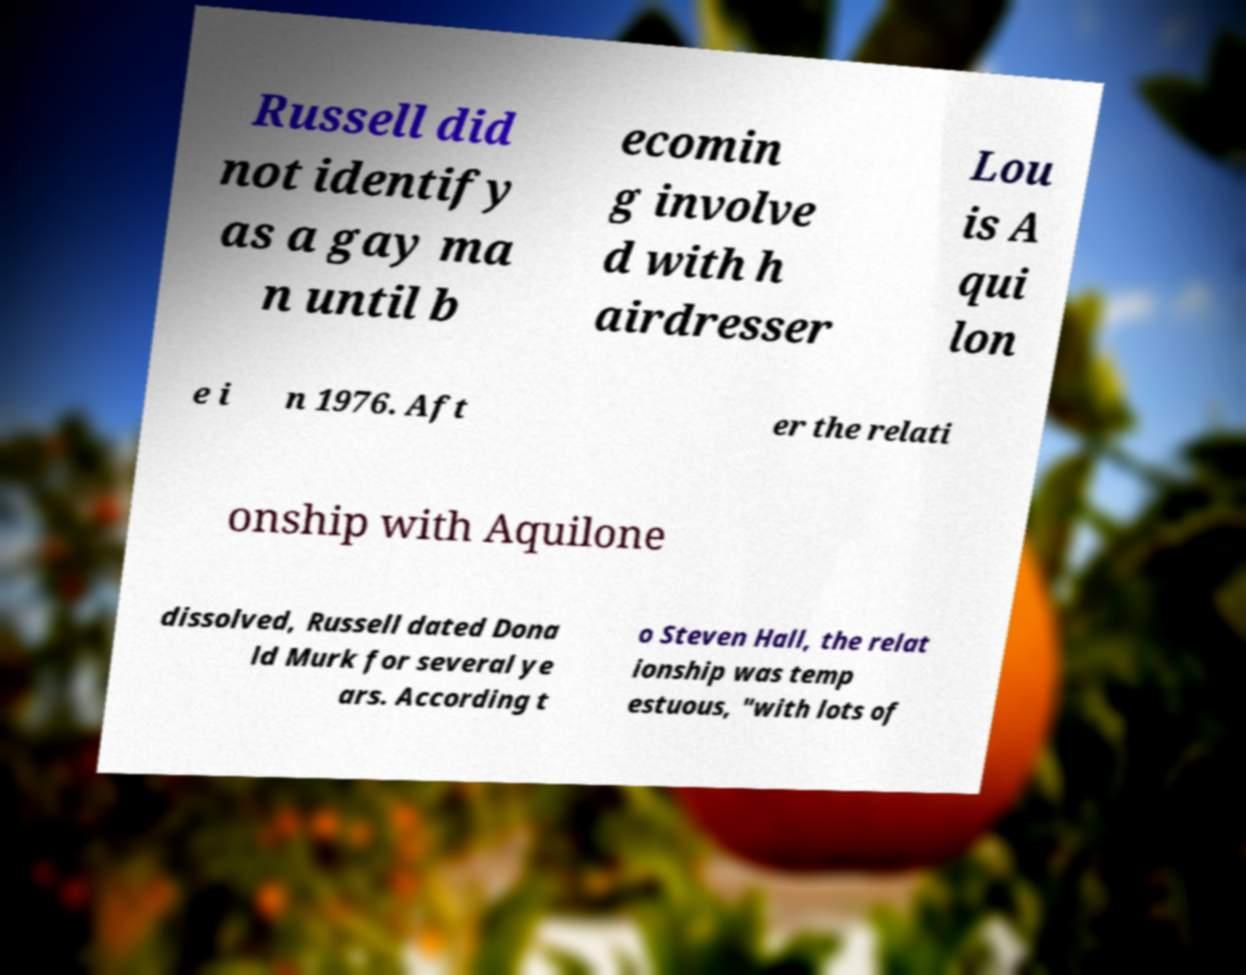Can you accurately transcribe the text from the provided image for me? Russell did not identify as a gay ma n until b ecomin g involve d with h airdresser Lou is A qui lon e i n 1976. Aft er the relati onship with Aquilone dissolved, Russell dated Dona ld Murk for several ye ars. According t o Steven Hall, the relat ionship was temp estuous, "with lots of 